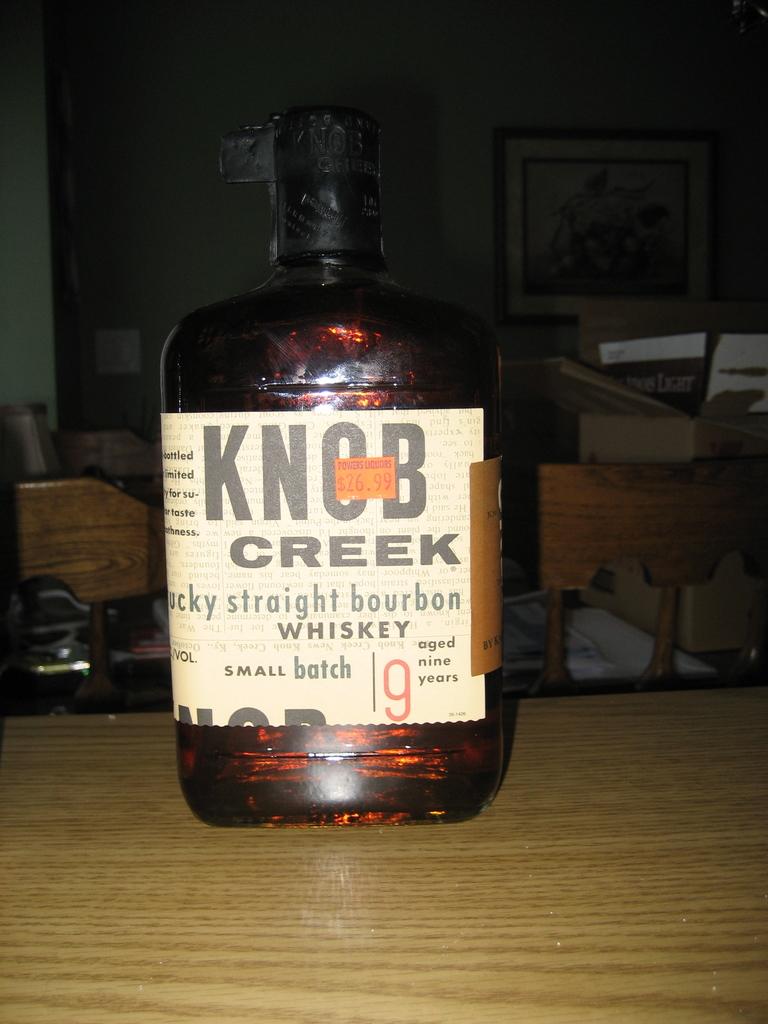How many years was this whiskey aged for?
Make the answer very short. 9. 